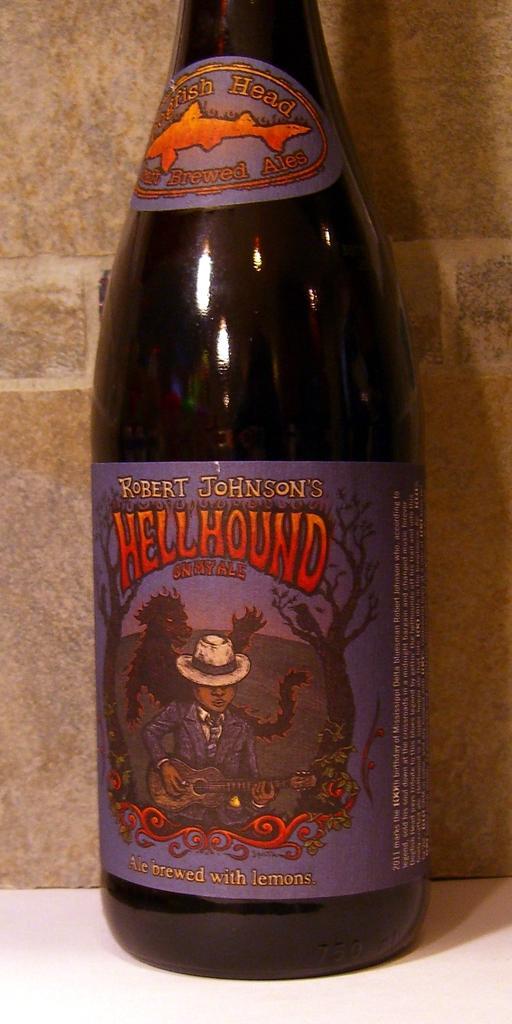How would you summarize this image in a sentence or two? In the center of this picture we can see a glass bottle and we can see the text and some pictures which includes a person seems to be playing guitar and we can see a bird standing on the branch of a tree and the picture of an animal and the pictures of some other objects on the paper attached to the glass. In the background we can see an object seems to be the wall and we can see some other objects. 